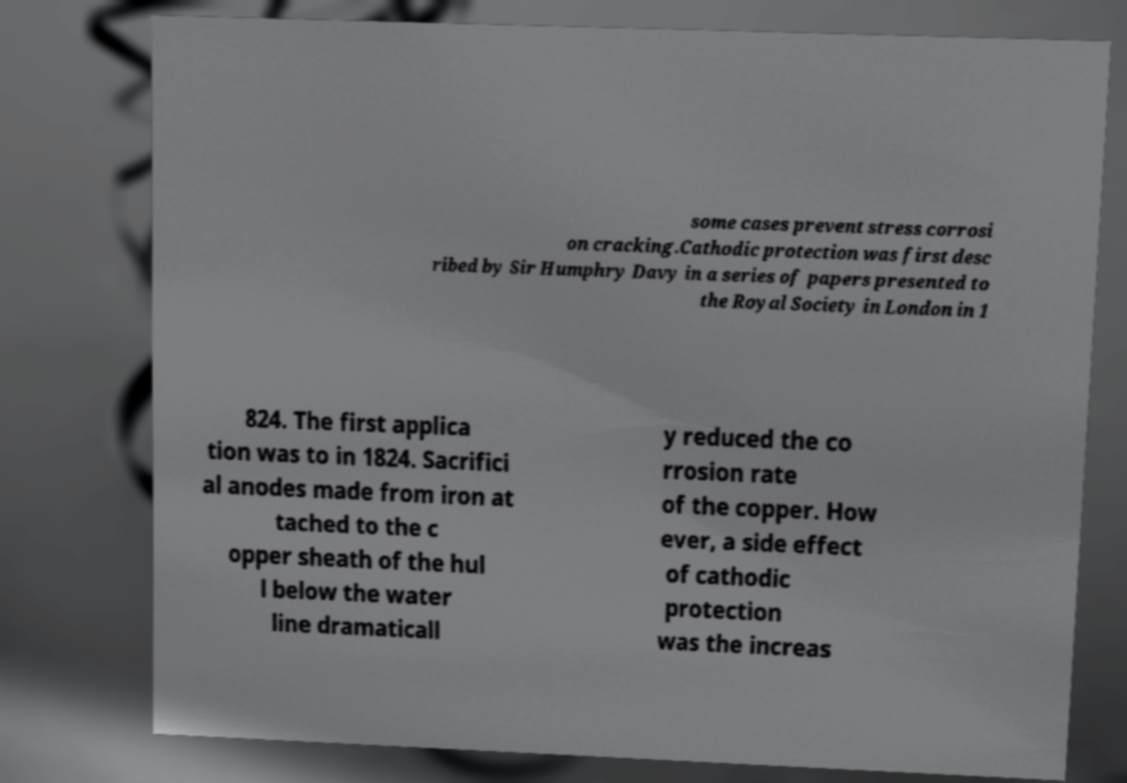Can you accurately transcribe the text from the provided image for me? some cases prevent stress corrosi on cracking.Cathodic protection was first desc ribed by Sir Humphry Davy in a series of papers presented to the Royal Society in London in 1 824. The first applica tion was to in 1824. Sacrifici al anodes made from iron at tached to the c opper sheath of the hul l below the water line dramaticall y reduced the co rrosion rate of the copper. How ever, a side effect of cathodic protection was the increas 